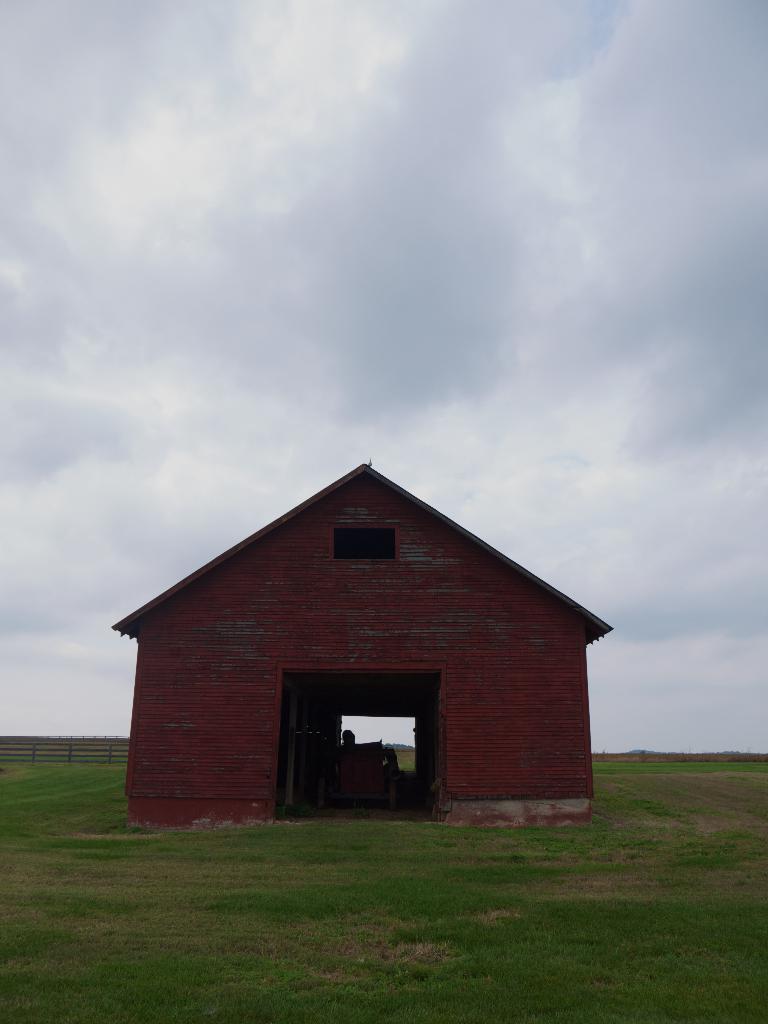Describe this image in one or two sentences. In this image, in the middle there is a house. At the bottom there is grass. In the background there is a fence, sky and clouds. 